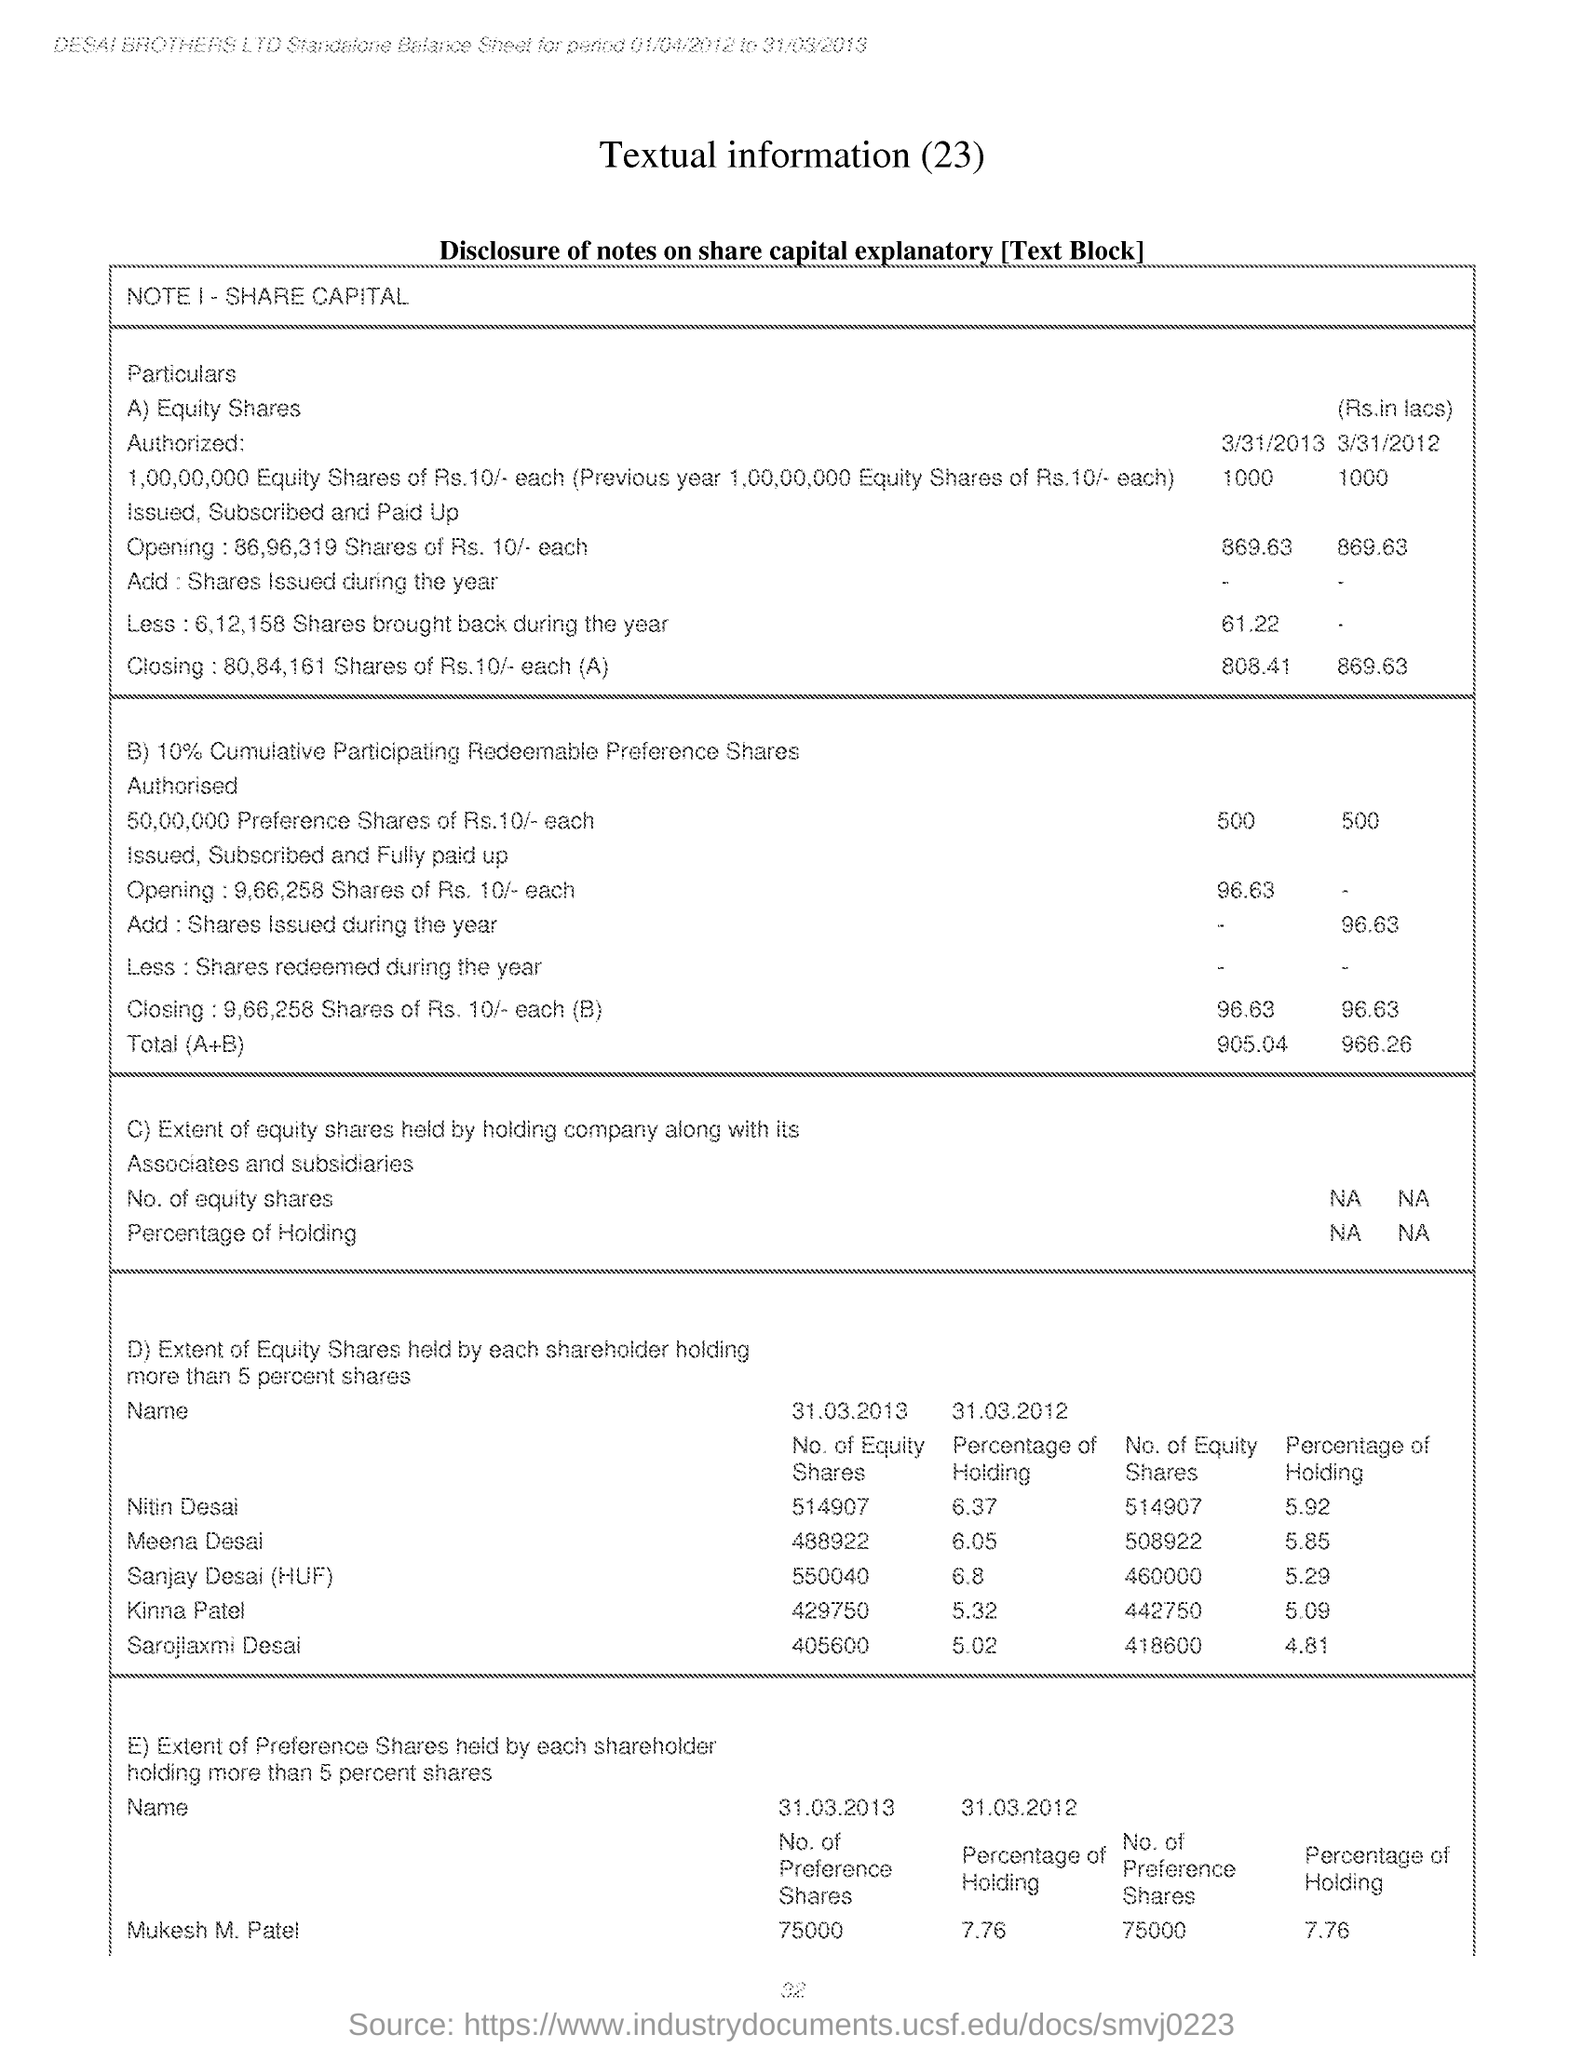What is the No. of Equity Shares held by Nitin Desai as on 31.03.2013?
Make the answer very short. 514907. What is the No. of Equity Shares held by Meena Desai as on 31.03.2013?
Keep it short and to the point. 488922. What is the Percentage of Holding for Kinna Patel as on 31.03.2012?
Ensure brevity in your answer.  5.32. What is the Percentage of Holding for Sarojlaxmi Desai as on 31.03.2012?
Your response must be concise. 5.02. What is the No. of Equity Shares held by Sanjay Desai (HUF) as on 31.03.2013?
Offer a very short reply. 550040. What is the No of Equity Shares held by Holding company along with its associates and subsidiaries?
Ensure brevity in your answer.  NA. 